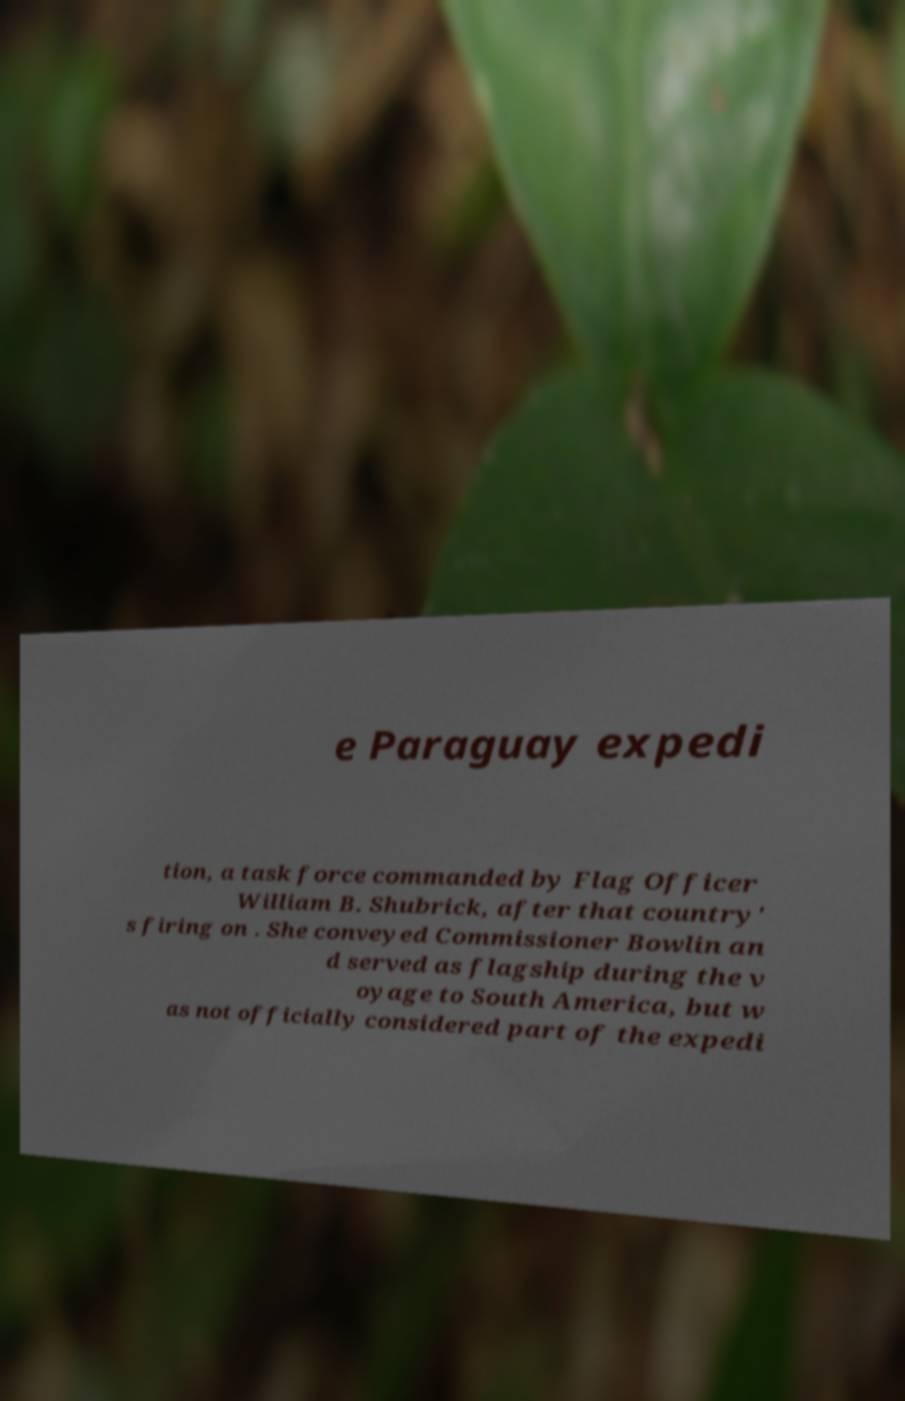Please identify and transcribe the text found in this image. e Paraguay expedi tion, a task force commanded by Flag Officer William B. Shubrick, after that country' s firing on . She conveyed Commissioner Bowlin an d served as flagship during the v oyage to South America, but w as not officially considered part of the expedi 